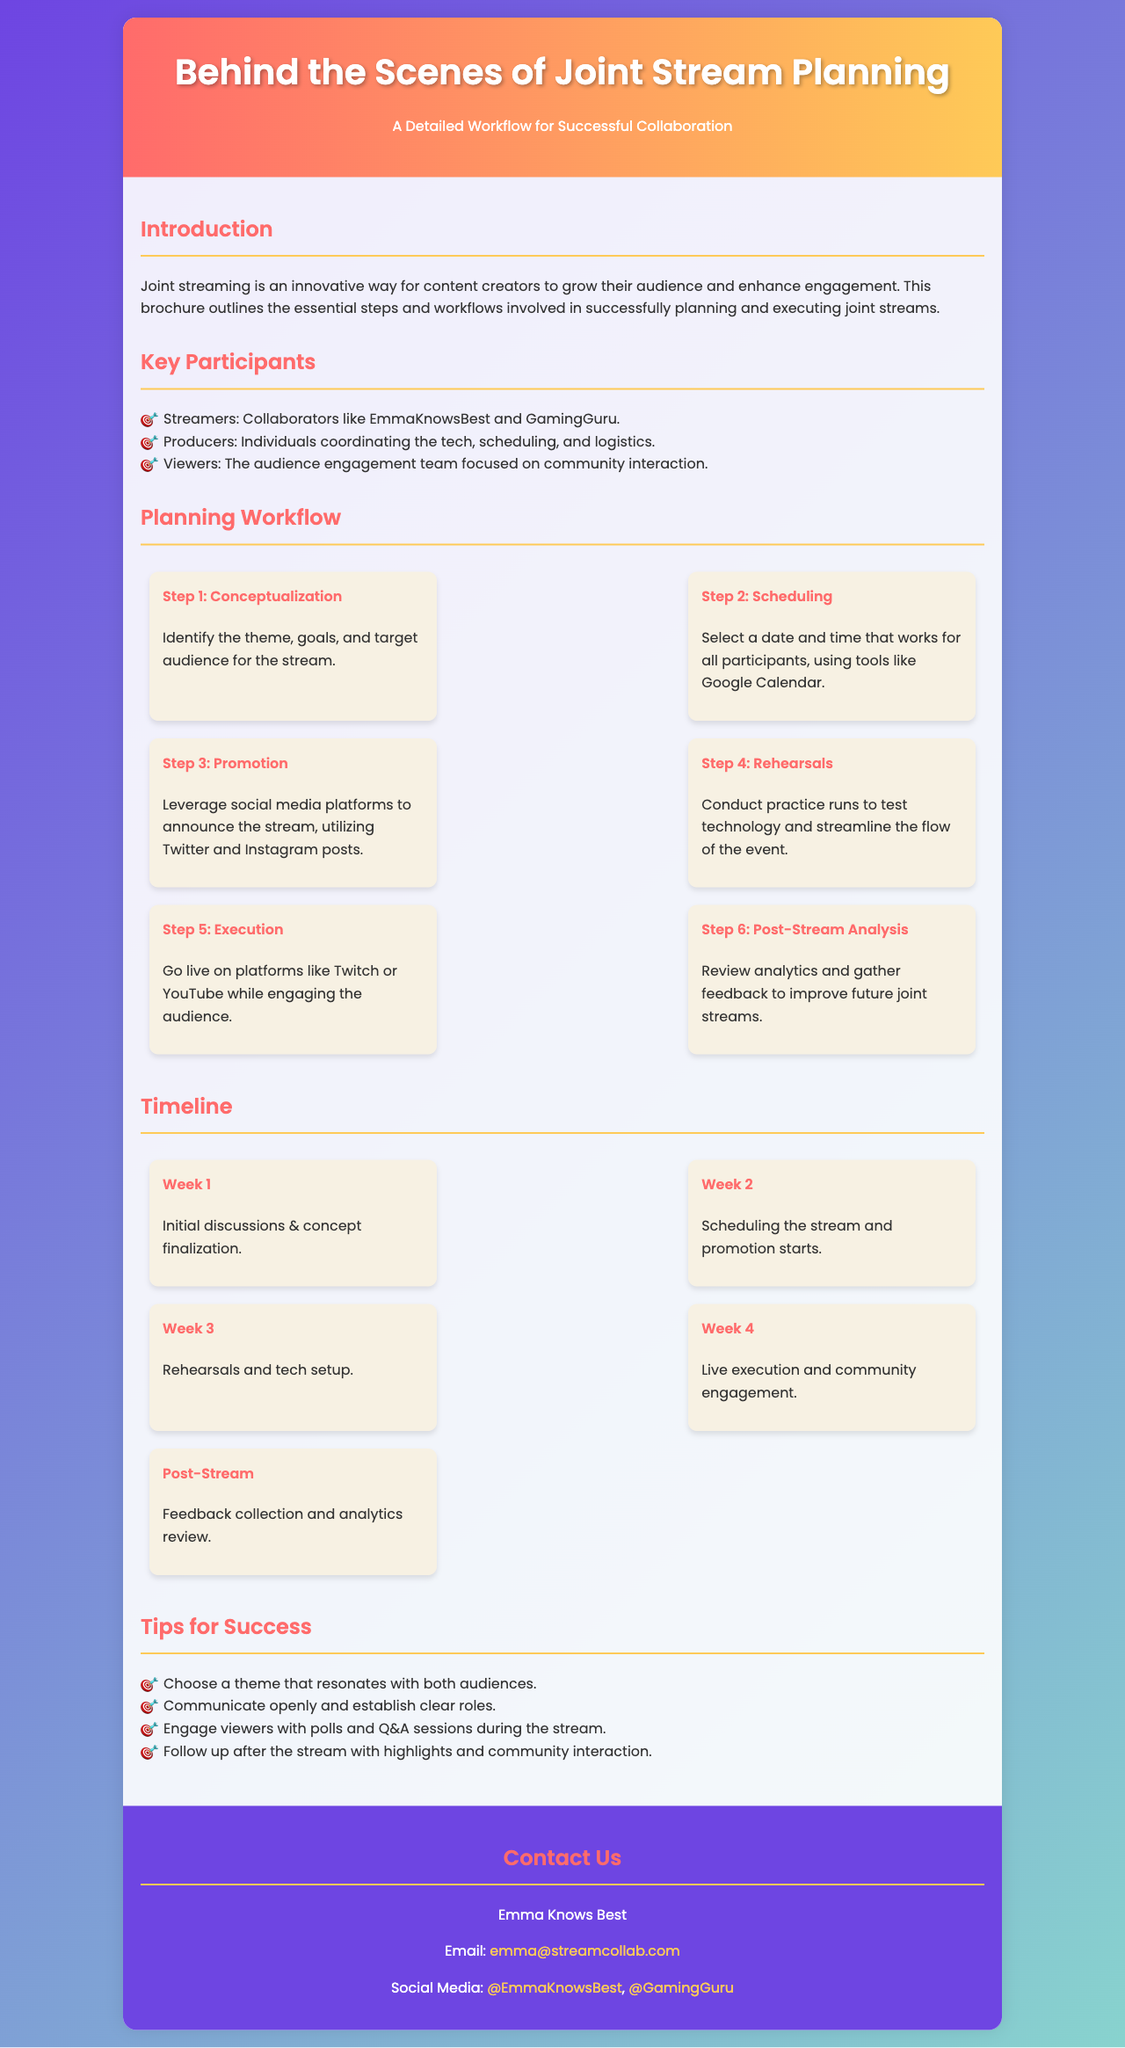What is the main theme of the brochure? The brochure outlines the essential steps and workflows involved in successfully planning and executing joint streams.
Answer: Joint streaming Who are the key participants listed? The document specifies the main participants involved in joint streams, which include streamers, producers, and viewers.
Answer: Streamers, Producers, Viewers What is the first step in the planning workflow? According to the document, the first step in the planning workflow focuses on identifying the theme, goals, and target audience.
Answer: Conceptualization What is the length of the timeline mentioned in the document? The timeline spans specific weeks for various activities leading up to and following the joint stream execution.
Answer: Four weeks Which platforms are mentioned for going live during the stream? The brochure lists the platforms used for live streaming which are popular among streamers and viewers.
Answer: Twitch or YouTube What is a tip given for successful joint streams? The document suggests strategies to enhance the effectiveness and reach of the joint streams.
Answer: Choose a theme that resonates with both audiences How can interested individuals contact Emma Knows Best? The brochure provides contact details for reaching out, specifically an email address for inquiries.
Answer: emma@streamcollab.com What happens during Week 3 according to the timeline? The timeline specifies different phases of preparation that occur each week leading up to the stream.
Answer: Rehearsals and tech setup 